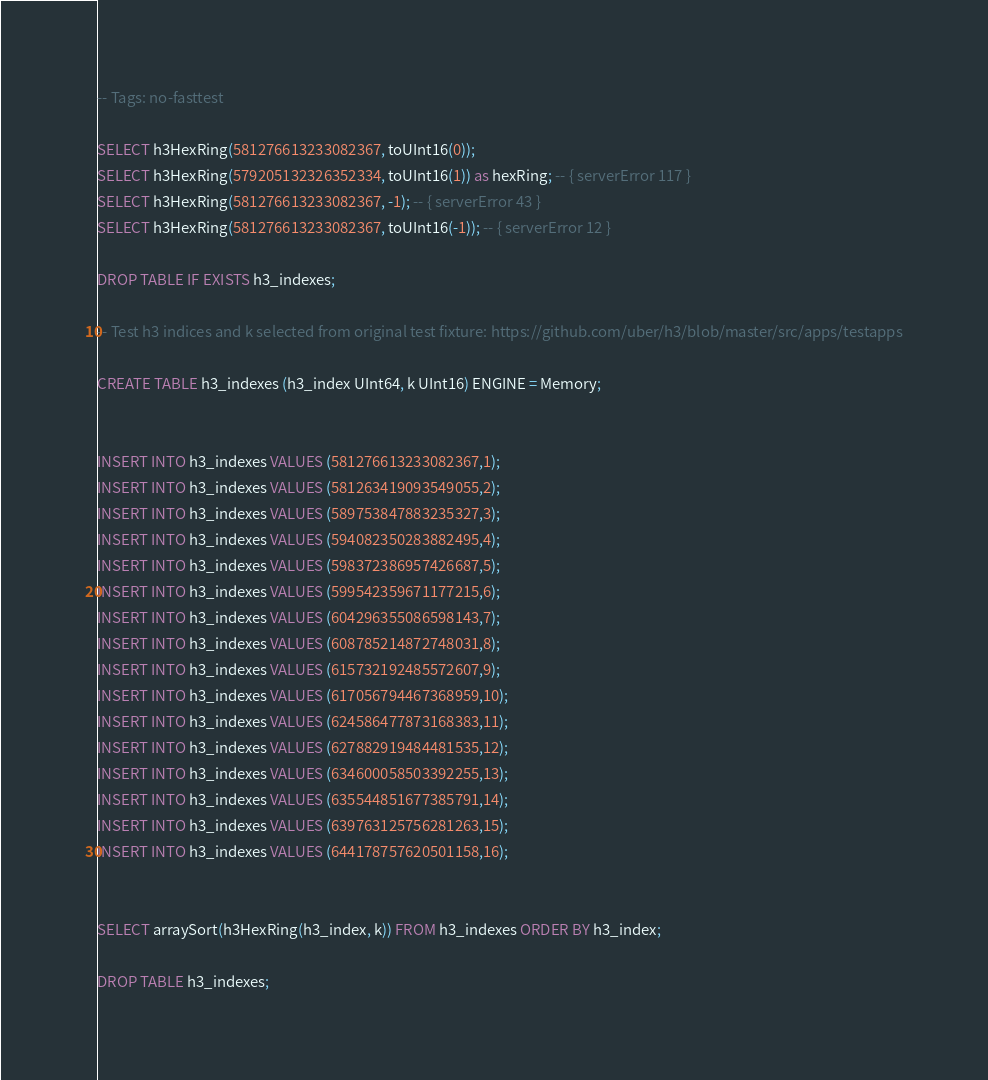Convert code to text. <code><loc_0><loc_0><loc_500><loc_500><_SQL_>-- Tags: no-fasttest

SELECT h3HexRing(581276613233082367, toUInt16(0));
SELECT h3HexRing(579205132326352334, toUInt16(1)) as hexRing; -- { serverError 117 }
SELECT h3HexRing(581276613233082367, -1); -- { serverError 43 }
SELECT h3HexRing(581276613233082367, toUInt16(-1)); -- { serverError 12 }

DROP TABLE IF EXISTS h3_indexes;

-- Test h3 indices and k selected from original test fixture: https://github.com/uber/h3/blob/master/src/apps/testapps

CREATE TABLE h3_indexes (h3_index UInt64, k UInt16) ENGINE = Memory;


INSERT INTO h3_indexes VALUES (581276613233082367,1);
INSERT INTO h3_indexes VALUES (581263419093549055,2);
INSERT INTO h3_indexes VALUES (589753847883235327,3);
INSERT INTO h3_indexes VALUES (594082350283882495,4);
INSERT INTO h3_indexes VALUES (598372386957426687,5);
INSERT INTO h3_indexes VALUES (599542359671177215,6);
INSERT INTO h3_indexes VALUES (604296355086598143,7);
INSERT INTO h3_indexes VALUES (608785214872748031,8);
INSERT INTO h3_indexes VALUES (615732192485572607,9);
INSERT INTO h3_indexes VALUES (617056794467368959,10);
INSERT INTO h3_indexes VALUES (624586477873168383,11);
INSERT INTO h3_indexes VALUES (627882919484481535,12);
INSERT INTO h3_indexes VALUES (634600058503392255,13);
INSERT INTO h3_indexes VALUES (635544851677385791,14);
INSERT INTO h3_indexes VALUES (639763125756281263,15);
INSERT INTO h3_indexes VALUES (644178757620501158,16);


SELECT arraySort(h3HexRing(h3_index, k)) FROM h3_indexes ORDER BY h3_index;

DROP TABLE h3_indexes;
</code> 